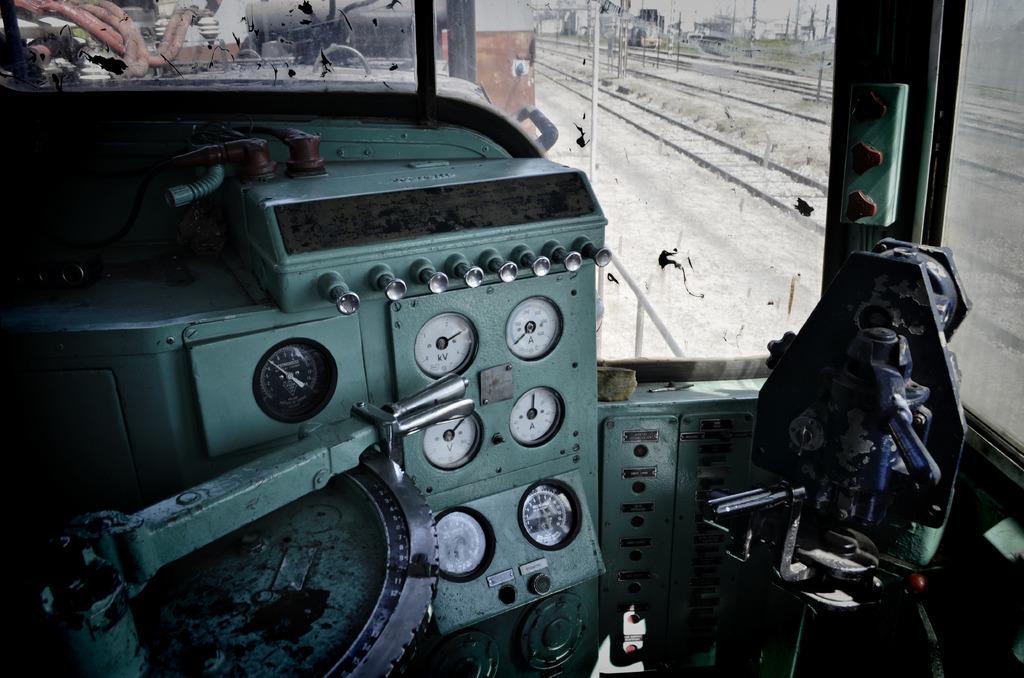Could you give a brief overview of what you see in this image? In this picture I can see the inside view of the train. In the center I can see the speedometer and other meters on the panel. Through the window and glass partition I can see the railway tracks, poles, buildings, electric wires and other objects. 